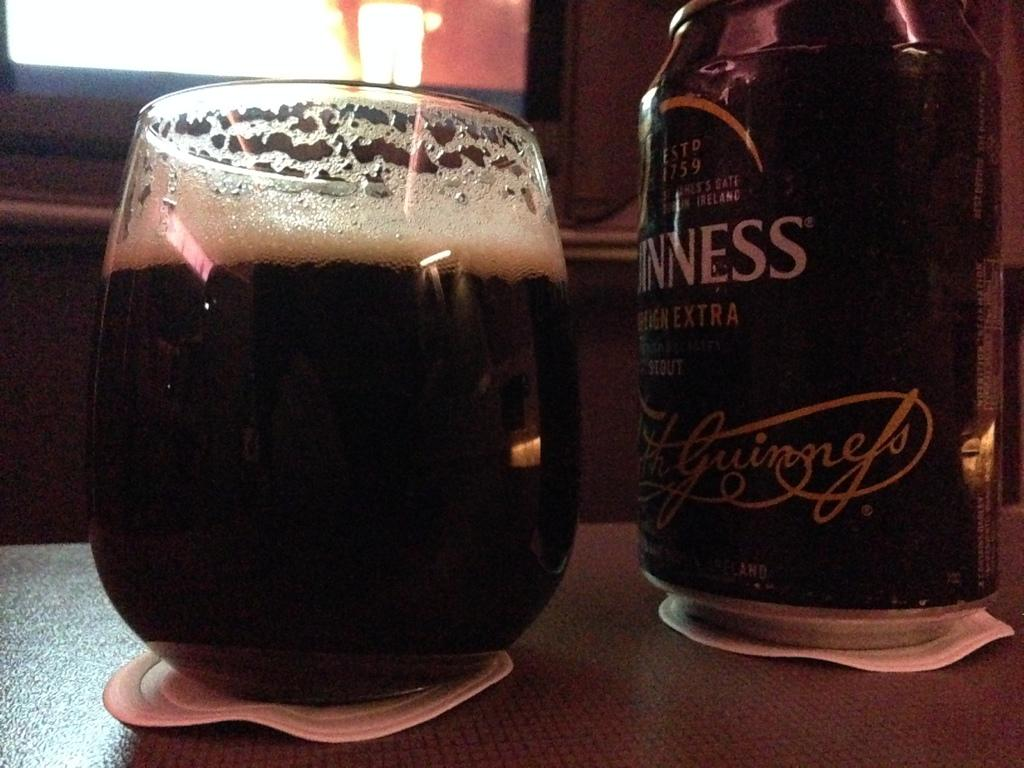<image>
Summarize the visual content of the image. A bottle of Guinness sits next to a full glass. 